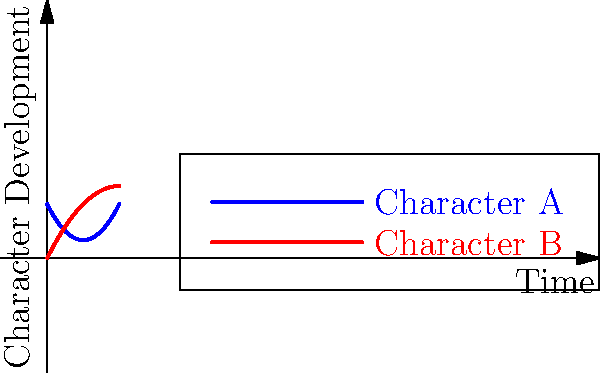In a screenplay you're writing, you've plotted the character arcs for two main characters using the graph above. The blue curve represents Character A, while the red curve represents Character B. Based on these arcs, which character experiences the most significant transformation by the end of the story, and why? To determine which character experiences the most significant transformation, we need to analyze the curves:

1. Character A (blue curve):
   - Starts at a higher point (y-intercept ≈ 3)
   - Initially decreases
   - Reaches a low point around x = 2
   - Then increases rapidly

2. Character B (red curve):
   - Starts at a lower point (y-intercept = 0)
   - Increases steadily
   - Reaches a peak around x = 4
   - Begins to plateau or slightly decrease at the end

3. Comparing the transformations:
   - Character A's arc shows a more dramatic change, starting high, falling, then rising again
   - Character B's arc shows steady growth but less overall change

4. Significance of transformation:
   - Character A experiences both negative and positive changes, suggesting a more complex journey
   - The steeper slope of Character A's curve at the end indicates a more rapid and significant change

5. Conclusion:
   Character A experiences the most significant transformation due to the greater overall change in their arc and the more dramatic shifts in their journey.
Answer: Character A, due to greater overall change and more dramatic shifts in their journey. 